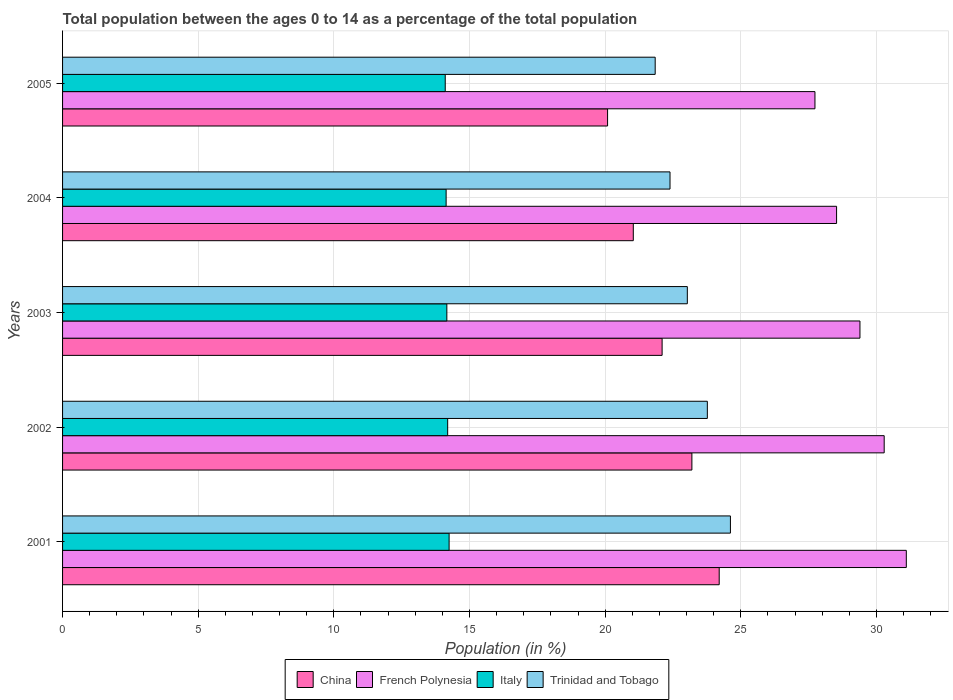How many different coloured bars are there?
Offer a very short reply. 4. How many groups of bars are there?
Offer a very short reply. 5. Are the number of bars per tick equal to the number of legend labels?
Your answer should be very brief. Yes. How many bars are there on the 5th tick from the bottom?
Provide a succinct answer. 4. In how many cases, is the number of bars for a given year not equal to the number of legend labels?
Offer a very short reply. 0. What is the percentage of the population ages 0 to 14 in China in 2002?
Offer a terse response. 23.2. Across all years, what is the maximum percentage of the population ages 0 to 14 in Italy?
Keep it short and to the point. 14.25. Across all years, what is the minimum percentage of the population ages 0 to 14 in China?
Your answer should be very brief. 20.09. In which year was the percentage of the population ages 0 to 14 in French Polynesia maximum?
Your answer should be very brief. 2001. What is the total percentage of the population ages 0 to 14 in Trinidad and Tobago in the graph?
Keep it short and to the point. 115.65. What is the difference between the percentage of the population ages 0 to 14 in Italy in 2001 and that in 2005?
Make the answer very short. 0.14. What is the difference between the percentage of the population ages 0 to 14 in French Polynesia in 2004 and the percentage of the population ages 0 to 14 in China in 2005?
Keep it short and to the point. 8.44. What is the average percentage of the population ages 0 to 14 in Italy per year?
Your response must be concise. 14.17. In the year 2005, what is the difference between the percentage of the population ages 0 to 14 in Trinidad and Tobago and percentage of the population ages 0 to 14 in Italy?
Provide a short and direct response. 7.74. In how many years, is the percentage of the population ages 0 to 14 in Italy greater than 1 ?
Keep it short and to the point. 5. What is the ratio of the percentage of the population ages 0 to 14 in Italy in 2001 to that in 2002?
Offer a terse response. 1. What is the difference between the highest and the second highest percentage of the population ages 0 to 14 in China?
Offer a very short reply. 1.01. What is the difference between the highest and the lowest percentage of the population ages 0 to 14 in China?
Your answer should be very brief. 4.11. In how many years, is the percentage of the population ages 0 to 14 in Italy greater than the average percentage of the population ages 0 to 14 in Italy taken over all years?
Give a very brief answer. 2. How many bars are there?
Your answer should be compact. 20. What is the difference between two consecutive major ticks on the X-axis?
Provide a short and direct response. 5. Are the values on the major ticks of X-axis written in scientific E-notation?
Give a very brief answer. No. Does the graph contain any zero values?
Your answer should be compact. No. Where does the legend appear in the graph?
Offer a terse response. Bottom center. How many legend labels are there?
Offer a very short reply. 4. What is the title of the graph?
Give a very brief answer. Total population between the ages 0 to 14 as a percentage of the total population. Does "Vanuatu" appear as one of the legend labels in the graph?
Provide a succinct answer. No. What is the label or title of the X-axis?
Offer a very short reply. Population (in %). What is the label or title of the Y-axis?
Keep it short and to the point. Years. What is the Population (in %) in China in 2001?
Make the answer very short. 24.2. What is the Population (in %) of French Polynesia in 2001?
Make the answer very short. 31.1. What is the Population (in %) in Italy in 2001?
Provide a short and direct response. 14.25. What is the Population (in %) in Trinidad and Tobago in 2001?
Provide a short and direct response. 24.62. What is the Population (in %) of China in 2002?
Offer a terse response. 23.2. What is the Population (in %) in French Polynesia in 2002?
Your response must be concise. 30.29. What is the Population (in %) of Italy in 2002?
Provide a succinct answer. 14.2. What is the Population (in %) of Trinidad and Tobago in 2002?
Your answer should be compact. 23.77. What is the Population (in %) in China in 2003?
Ensure brevity in your answer.  22.1. What is the Population (in %) in French Polynesia in 2003?
Give a very brief answer. 29.39. What is the Population (in %) in Italy in 2003?
Provide a succinct answer. 14.16. What is the Population (in %) of Trinidad and Tobago in 2003?
Your answer should be compact. 23.03. What is the Population (in %) of China in 2004?
Give a very brief answer. 21.04. What is the Population (in %) of French Polynesia in 2004?
Ensure brevity in your answer.  28.53. What is the Population (in %) in Italy in 2004?
Give a very brief answer. 14.14. What is the Population (in %) in Trinidad and Tobago in 2004?
Your answer should be compact. 22.39. What is the Population (in %) in China in 2005?
Offer a terse response. 20.09. What is the Population (in %) in French Polynesia in 2005?
Provide a succinct answer. 27.73. What is the Population (in %) in Italy in 2005?
Give a very brief answer. 14.11. What is the Population (in %) of Trinidad and Tobago in 2005?
Your answer should be compact. 21.84. Across all years, what is the maximum Population (in %) in China?
Keep it short and to the point. 24.2. Across all years, what is the maximum Population (in %) of French Polynesia?
Give a very brief answer. 31.1. Across all years, what is the maximum Population (in %) in Italy?
Your answer should be very brief. 14.25. Across all years, what is the maximum Population (in %) in Trinidad and Tobago?
Offer a very short reply. 24.62. Across all years, what is the minimum Population (in %) in China?
Your response must be concise. 20.09. Across all years, what is the minimum Population (in %) of French Polynesia?
Ensure brevity in your answer.  27.73. Across all years, what is the minimum Population (in %) of Italy?
Give a very brief answer. 14.11. Across all years, what is the minimum Population (in %) of Trinidad and Tobago?
Provide a short and direct response. 21.84. What is the total Population (in %) in China in the graph?
Provide a succinct answer. 110.63. What is the total Population (in %) in French Polynesia in the graph?
Your response must be concise. 147.04. What is the total Population (in %) of Italy in the graph?
Make the answer very short. 70.85. What is the total Population (in %) of Trinidad and Tobago in the graph?
Your answer should be compact. 115.65. What is the difference between the Population (in %) in China in 2001 and that in 2002?
Your answer should be compact. 1.01. What is the difference between the Population (in %) in French Polynesia in 2001 and that in 2002?
Your response must be concise. 0.82. What is the difference between the Population (in %) of Italy in 2001 and that in 2002?
Provide a succinct answer. 0.05. What is the difference between the Population (in %) in Trinidad and Tobago in 2001 and that in 2002?
Your answer should be compact. 0.85. What is the difference between the Population (in %) in China in 2001 and that in 2003?
Keep it short and to the point. 2.1. What is the difference between the Population (in %) in French Polynesia in 2001 and that in 2003?
Provide a succinct answer. 1.71. What is the difference between the Population (in %) of Italy in 2001 and that in 2003?
Make the answer very short. 0.08. What is the difference between the Population (in %) in Trinidad and Tobago in 2001 and that in 2003?
Provide a short and direct response. 1.59. What is the difference between the Population (in %) in China in 2001 and that in 2004?
Offer a very short reply. 3.17. What is the difference between the Population (in %) in French Polynesia in 2001 and that in 2004?
Provide a short and direct response. 2.57. What is the difference between the Population (in %) of Italy in 2001 and that in 2004?
Ensure brevity in your answer.  0.11. What is the difference between the Population (in %) in Trinidad and Tobago in 2001 and that in 2004?
Offer a terse response. 2.23. What is the difference between the Population (in %) in China in 2001 and that in 2005?
Make the answer very short. 4.11. What is the difference between the Population (in %) of French Polynesia in 2001 and that in 2005?
Ensure brevity in your answer.  3.37. What is the difference between the Population (in %) of Italy in 2001 and that in 2005?
Provide a short and direct response. 0.14. What is the difference between the Population (in %) of Trinidad and Tobago in 2001 and that in 2005?
Your answer should be compact. 2.77. What is the difference between the Population (in %) in China in 2002 and that in 2003?
Ensure brevity in your answer.  1.1. What is the difference between the Population (in %) in French Polynesia in 2002 and that in 2003?
Give a very brief answer. 0.89. What is the difference between the Population (in %) in Italy in 2002 and that in 2003?
Offer a terse response. 0.03. What is the difference between the Population (in %) in Trinidad and Tobago in 2002 and that in 2003?
Provide a short and direct response. 0.74. What is the difference between the Population (in %) in China in 2002 and that in 2004?
Ensure brevity in your answer.  2.16. What is the difference between the Population (in %) in French Polynesia in 2002 and that in 2004?
Provide a short and direct response. 1.75. What is the difference between the Population (in %) in Italy in 2002 and that in 2004?
Offer a terse response. 0.06. What is the difference between the Population (in %) in Trinidad and Tobago in 2002 and that in 2004?
Provide a short and direct response. 1.38. What is the difference between the Population (in %) of China in 2002 and that in 2005?
Offer a terse response. 3.11. What is the difference between the Population (in %) of French Polynesia in 2002 and that in 2005?
Give a very brief answer. 2.55. What is the difference between the Population (in %) of Italy in 2002 and that in 2005?
Your answer should be very brief. 0.09. What is the difference between the Population (in %) in Trinidad and Tobago in 2002 and that in 2005?
Your answer should be compact. 1.92. What is the difference between the Population (in %) in China in 2003 and that in 2004?
Ensure brevity in your answer.  1.06. What is the difference between the Population (in %) in French Polynesia in 2003 and that in 2004?
Your answer should be very brief. 0.86. What is the difference between the Population (in %) of Italy in 2003 and that in 2004?
Make the answer very short. 0.03. What is the difference between the Population (in %) in Trinidad and Tobago in 2003 and that in 2004?
Your response must be concise. 0.64. What is the difference between the Population (in %) in China in 2003 and that in 2005?
Your answer should be compact. 2.01. What is the difference between the Population (in %) of French Polynesia in 2003 and that in 2005?
Offer a terse response. 1.66. What is the difference between the Population (in %) of Italy in 2003 and that in 2005?
Your answer should be compact. 0.06. What is the difference between the Population (in %) of Trinidad and Tobago in 2003 and that in 2005?
Provide a short and direct response. 1.18. What is the difference between the Population (in %) in China in 2004 and that in 2005?
Provide a succinct answer. 0.95. What is the difference between the Population (in %) in French Polynesia in 2004 and that in 2005?
Give a very brief answer. 0.8. What is the difference between the Population (in %) of Italy in 2004 and that in 2005?
Ensure brevity in your answer.  0.03. What is the difference between the Population (in %) of Trinidad and Tobago in 2004 and that in 2005?
Your response must be concise. 0.55. What is the difference between the Population (in %) in China in 2001 and the Population (in %) in French Polynesia in 2002?
Make the answer very short. -6.08. What is the difference between the Population (in %) of China in 2001 and the Population (in %) of Italy in 2002?
Provide a short and direct response. 10.01. What is the difference between the Population (in %) in China in 2001 and the Population (in %) in Trinidad and Tobago in 2002?
Ensure brevity in your answer.  0.44. What is the difference between the Population (in %) of French Polynesia in 2001 and the Population (in %) of Italy in 2002?
Ensure brevity in your answer.  16.91. What is the difference between the Population (in %) in French Polynesia in 2001 and the Population (in %) in Trinidad and Tobago in 2002?
Offer a terse response. 7.33. What is the difference between the Population (in %) in Italy in 2001 and the Population (in %) in Trinidad and Tobago in 2002?
Provide a succinct answer. -9.52. What is the difference between the Population (in %) in China in 2001 and the Population (in %) in French Polynesia in 2003?
Offer a terse response. -5.19. What is the difference between the Population (in %) of China in 2001 and the Population (in %) of Italy in 2003?
Ensure brevity in your answer.  10.04. What is the difference between the Population (in %) of China in 2001 and the Population (in %) of Trinidad and Tobago in 2003?
Your answer should be compact. 1.17. What is the difference between the Population (in %) in French Polynesia in 2001 and the Population (in %) in Italy in 2003?
Ensure brevity in your answer.  16.94. What is the difference between the Population (in %) of French Polynesia in 2001 and the Population (in %) of Trinidad and Tobago in 2003?
Provide a succinct answer. 8.07. What is the difference between the Population (in %) in Italy in 2001 and the Population (in %) in Trinidad and Tobago in 2003?
Make the answer very short. -8.78. What is the difference between the Population (in %) of China in 2001 and the Population (in %) of French Polynesia in 2004?
Offer a terse response. -4.33. What is the difference between the Population (in %) in China in 2001 and the Population (in %) in Italy in 2004?
Offer a terse response. 10.07. What is the difference between the Population (in %) in China in 2001 and the Population (in %) in Trinidad and Tobago in 2004?
Provide a succinct answer. 1.81. What is the difference between the Population (in %) of French Polynesia in 2001 and the Population (in %) of Italy in 2004?
Give a very brief answer. 16.96. What is the difference between the Population (in %) of French Polynesia in 2001 and the Population (in %) of Trinidad and Tobago in 2004?
Provide a succinct answer. 8.71. What is the difference between the Population (in %) of Italy in 2001 and the Population (in %) of Trinidad and Tobago in 2004?
Provide a short and direct response. -8.14. What is the difference between the Population (in %) of China in 2001 and the Population (in %) of French Polynesia in 2005?
Your response must be concise. -3.53. What is the difference between the Population (in %) of China in 2001 and the Population (in %) of Italy in 2005?
Offer a terse response. 10.1. What is the difference between the Population (in %) in China in 2001 and the Population (in %) in Trinidad and Tobago in 2005?
Provide a succinct answer. 2.36. What is the difference between the Population (in %) in French Polynesia in 2001 and the Population (in %) in Italy in 2005?
Provide a succinct answer. 17. What is the difference between the Population (in %) in French Polynesia in 2001 and the Population (in %) in Trinidad and Tobago in 2005?
Keep it short and to the point. 9.26. What is the difference between the Population (in %) in Italy in 2001 and the Population (in %) in Trinidad and Tobago in 2005?
Provide a short and direct response. -7.6. What is the difference between the Population (in %) in China in 2002 and the Population (in %) in French Polynesia in 2003?
Your response must be concise. -6.2. What is the difference between the Population (in %) of China in 2002 and the Population (in %) of Italy in 2003?
Offer a terse response. 9.03. What is the difference between the Population (in %) in China in 2002 and the Population (in %) in Trinidad and Tobago in 2003?
Offer a very short reply. 0.17. What is the difference between the Population (in %) in French Polynesia in 2002 and the Population (in %) in Italy in 2003?
Your answer should be very brief. 16.12. What is the difference between the Population (in %) of French Polynesia in 2002 and the Population (in %) of Trinidad and Tobago in 2003?
Make the answer very short. 7.26. What is the difference between the Population (in %) of Italy in 2002 and the Population (in %) of Trinidad and Tobago in 2003?
Give a very brief answer. -8.83. What is the difference between the Population (in %) of China in 2002 and the Population (in %) of French Polynesia in 2004?
Your answer should be very brief. -5.33. What is the difference between the Population (in %) of China in 2002 and the Population (in %) of Italy in 2004?
Your response must be concise. 9.06. What is the difference between the Population (in %) in China in 2002 and the Population (in %) in Trinidad and Tobago in 2004?
Your response must be concise. 0.81. What is the difference between the Population (in %) of French Polynesia in 2002 and the Population (in %) of Italy in 2004?
Your answer should be very brief. 16.15. What is the difference between the Population (in %) in French Polynesia in 2002 and the Population (in %) in Trinidad and Tobago in 2004?
Provide a short and direct response. 7.89. What is the difference between the Population (in %) in Italy in 2002 and the Population (in %) in Trinidad and Tobago in 2004?
Keep it short and to the point. -8.2. What is the difference between the Population (in %) of China in 2002 and the Population (in %) of French Polynesia in 2005?
Ensure brevity in your answer.  -4.54. What is the difference between the Population (in %) of China in 2002 and the Population (in %) of Italy in 2005?
Provide a succinct answer. 9.09. What is the difference between the Population (in %) in China in 2002 and the Population (in %) in Trinidad and Tobago in 2005?
Your answer should be compact. 1.35. What is the difference between the Population (in %) in French Polynesia in 2002 and the Population (in %) in Italy in 2005?
Your answer should be compact. 16.18. What is the difference between the Population (in %) in French Polynesia in 2002 and the Population (in %) in Trinidad and Tobago in 2005?
Ensure brevity in your answer.  8.44. What is the difference between the Population (in %) of Italy in 2002 and the Population (in %) of Trinidad and Tobago in 2005?
Offer a very short reply. -7.65. What is the difference between the Population (in %) of China in 2003 and the Population (in %) of French Polynesia in 2004?
Your answer should be very brief. -6.43. What is the difference between the Population (in %) of China in 2003 and the Population (in %) of Italy in 2004?
Offer a terse response. 7.96. What is the difference between the Population (in %) of China in 2003 and the Population (in %) of Trinidad and Tobago in 2004?
Make the answer very short. -0.29. What is the difference between the Population (in %) in French Polynesia in 2003 and the Population (in %) in Italy in 2004?
Your answer should be compact. 15.25. What is the difference between the Population (in %) of French Polynesia in 2003 and the Population (in %) of Trinidad and Tobago in 2004?
Give a very brief answer. 7. What is the difference between the Population (in %) in Italy in 2003 and the Population (in %) in Trinidad and Tobago in 2004?
Keep it short and to the point. -8.23. What is the difference between the Population (in %) in China in 2003 and the Population (in %) in French Polynesia in 2005?
Provide a succinct answer. -5.63. What is the difference between the Population (in %) of China in 2003 and the Population (in %) of Italy in 2005?
Give a very brief answer. 7.99. What is the difference between the Population (in %) in China in 2003 and the Population (in %) in Trinidad and Tobago in 2005?
Provide a short and direct response. 0.26. What is the difference between the Population (in %) in French Polynesia in 2003 and the Population (in %) in Italy in 2005?
Ensure brevity in your answer.  15.29. What is the difference between the Population (in %) of French Polynesia in 2003 and the Population (in %) of Trinidad and Tobago in 2005?
Your response must be concise. 7.55. What is the difference between the Population (in %) of Italy in 2003 and the Population (in %) of Trinidad and Tobago in 2005?
Provide a short and direct response. -7.68. What is the difference between the Population (in %) in China in 2004 and the Population (in %) in French Polynesia in 2005?
Make the answer very short. -6.7. What is the difference between the Population (in %) of China in 2004 and the Population (in %) of Italy in 2005?
Give a very brief answer. 6.93. What is the difference between the Population (in %) in China in 2004 and the Population (in %) in Trinidad and Tobago in 2005?
Ensure brevity in your answer.  -0.81. What is the difference between the Population (in %) in French Polynesia in 2004 and the Population (in %) in Italy in 2005?
Offer a very short reply. 14.43. What is the difference between the Population (in %) in French Polynesia in 2004 and the Population (in %) in Trinidad and Tobago in 2005?
Offer a terse response. 6.69. What is the difference between the Population (in %) in Italy in 2004 and the Population (in %) in Trinidad and Tobago in 2005?
Your answer should be compact. -7.71. What is the average Population (in %) in China per year?
Keep it short and to the point. 22.13. What is the average Population (in %) in French Polynesia per year?
Provide a short and direct response. 29.41. What is the average Population (in %) of Italy per year?
Ensure brevity in your answer.  14.17. What is the average Population (in %) in Trinidad and Tobago per year?
Keep it short and to the point. 23.13. In the year 2001, what is the difference between the Population (in %) of China and Population (in %) of French Polynesia?
Provide a succinct answer. -6.9. In the year 2001, what is the difference between the Population (in %) of China and Population (in %) of Italy?
Offer a terse response. 9.96. In the year 2001, what is the difference between the Population (in %) in China and Population (in %) in Trinidad and Tobago?
Give a very brief answer. -0.41. In the year 2001, what is the difference between the Population (in %) in French Polynesia and Population (in %) in Italy?
Keep it short and to the point. 16.85. In the year 2001, what is the difference between the Population (in %) in French Polynesia and Population (in %) in Trinidad and Tobago?
Keep it short and to the point. 6.48. In the year 2001, what is the difference between the Population (in %) in Italy and Population (in %) in Trinidad and Tobago?
Your answer should be compact. -10.37. In the year 2002, what is the difference between the Population (in %) in China and Population (in %) in French Polynesia?
Your answer should be very brief. -7.09. In the year 2002, what is the difference between the Population (in %) in China and Population (in %) in Italy?
Keep it short and to the point. 9. In the year 2002, what is the difference between the Population (in %) in China and Population (in %) in Trinidad and Tobago?
Ensure brevity in your answer.  -0.57. In the year 2002, what is the difference between the Population (in %) in French Polynesia and Population (in %) in Italy?
Offer a very short reply. 16.09. In the year 2002, what is the difference between the Population (in %) of French Polynesia and Population (in %) of Trinidad and Tobago?
Keep it short and to the point. 6.52. In the year 2002, what is the difference between the Population (in %) of Italy and Population (in %) of Trinidad and Tobago?
Provide a short and direct response. -9.57. In the year 2003, what is the difference between the Population (in %) in China and Population (in %) in French Polynesia?
Ensure brevity in your answer.  -7.29. In the year 2003, what is the difference between the Population (in %) of China and Population (in %) of Italy?
Make the answer very short. 7.94. In the year 2003, what is the difference between the Population (in %) in China and Population (in %) in Trinidad and Tobago?
Your response must be concise. -0.93. In the year 2003, what is the difference between the Population (in %) in French Polynesia and Population (in %) in Italy?
Offer a terse response. 15.23. In the year 2003, what is the difference between the Population (in %) in French Polynesia and Population (in %) in Trinidad and Tobago?
Your response must be concise. 6.36. In the year 2003, what is the difference between the Population (in %) in Italy and Population (in %) in Trinidad and Tobago?
Offer a very short reply. -8.86. In the year 2004, what is the difference between the Population (in %) of China and Population (in %) of French Polynesia?
Your answer should be compact. -7.49. In the year 2004, what is the difference between the Population (in %) in China and Population (in %) in Italy?
Provide a succinct answer. 6.9. In the year 2004, what is the difference between the Population (in %) of China and Population (in %) of Trinidad and Tobago?
Ensure brevity in your answer.  -1.35. In the year 2004, what is the difference between the Population (in %) in French Polynesia and Population (in %) in Italy?
Your response must be concise. 14.39. In the year 2004, what is the difference between the Population (in %) in French Polynesia and Population (in %) in Trinidad and Tobago?
Make the answer very short. 6.14. In the year 2004, what is the difference between the Population (in %) of Italy and Population (in %) of Trinidad and Tobago?
Offer a very short reply. -8.25. In the year 2005, what is the difference between the Population (in %) of China and Population (in %) of French Polynesia?
Keep it short and to the point. -7.64. In the year 2005, what is the difference between the Population (in %) in China and Population (in %) in Italy?
Provide a succinct answer. 5.98. In the year 2005, what is the difference between the Population (in %) in China and Population (in %) in Trinidad and Tobago?
Keep it short and to the point. -1.76. In the year 2005, what is the difference between the Population (in %) in French Polynesia and Population (in %) in Italy?
Make the answer very short. 13.63. In the year 2005, what is the difference between the Population (in %) in French Polynesia and Population (in %) in Trinidad and Tobago?
Your answer should be compact. 5.89. In the year 2005, what is the difference between the Population (in %) of Italy and Population (in %) of Trinidad and Tobago?
Offer a very short reply. -7.74. What is the ratio of the Population (in %) in China in 2001 to that in 2002?
Give a very brief answer. 1.04. What is the ratio of the Population (in %) of French Polynesia in 2001 to that in 2002?
Give a very brief answer. 1.03. What is the ratio of the Population (in %) of Italy in 2001 to that in 2002?
Provide a short and direct response. 1. What is the ratio of the Population (in %) in Trinidad and Tobago in 2001 to that in 2002?
Keep it short and to the point. 1.04. What is the ratio of the Population (in %) in China in 2001 to that in 2003?
Your answer should be compact. 1.1. What is the ratio of the Population (in %) of French Polynesia in 2001 to that in 2003?
Ensure brevity in your answer.  1.06. What is the ratio of the Population (in %) of Italy in 2001 to that in 2003?
Provide a succinct answer. 1.01. What is the ratio of the Population (in %) in Trinidad and Tobago in 2001 to that in 2003?
Your answer should be very brief. 1.07. What is the ratio of the Population (in %) in China in 2001 to that in 2004?
Your answer should be compact. 1.15. What is the ratio of the Population (in %) in French Polynesia in 2001 to that in 2004?
Provide a succinct answer. 1.09. What is the ratio of the Population (in %) of Italy in 2001 to that in 2004?
Give a very brief answer. 1.01. What is the ratio of the Population (in %) in Trinidad and Tobago in 2001 to that in 2004?
Keep it short and to the point. 1.1. What is the ratio of the Population (in %) in China in 2001 to that in 2005?
Your answer should be very brief. 1.2. What is the ratio of the Population (in %) in French Polynesia in 2001 to that in 2005?
Your answer should be very brief. 1.12. What is the ratio of the Population (in %) of Italy in 2001 to that in 2005?
Provide a succinct answer. 1.01. What is the ratio of the Population (in %) of Trinidad and Tobago in 2001 to that in 2005?
Make the answer very short. 1.13. What is the ratio of the Population (in %) in China in 2002 to that in 2003?
Keep it short and to the point. 1.05. What is the ratio of the Population (in %) in French Polynesia in 2002 to that in 2003?
Your response must be concise. 1.03. What is the ratio of the Population (in %) in Trinidad and Tobago in 2002 to that in 2003?
Your answer should be very brief. 1.03. What is the ratio of the Population (in %) in China in 2002 to that in 2004?
Provide a short and direct response. 1.1. What is the ratio of the Population (in %) of French Polynesia in 2002 to that in 2004?
Keep it short and to the point. 1.06. What is the ratio of the Population (in %) of Italy in 2002 to that in 2004?
Provide a succinct answer. 1. What is the ratio of the Population (in %) of Trinidad and Tobago in 2002 to that in 2004?
Your answer should be compact. 1.06. What is the ratio of the Population (in %) of China in 2002 to that in 2005?
Keep it short and to the point. 1.15. What is the ratio of the Population (in %) in French Polynesia in 2002 to that in 2005?
Provide a succinct answer. 1.09. What is the ratio of the Population (in %) of Italy in 2002 to that in 2005?
Make the answer very short. 1.01. What is the ratio of the Population (in %) in Trinidad and Tobago in 2002 to that in 2005?
Make the answer very short. 1.09. What is the ratio of the Population (in %) of China in 2003 to that in 2004?
Your response must be concise. 1.05. What is the ratio of the Population (in %) in French Polynesia in 2003 to that in 2004?
Your answer should be compact. 1.03. What is the ratio of the Population (in %) in Trinidad and Tobago in 2003 to that in 2004?
Give a very brief answer. 1.03. What is the ratio of the Population (in %) of China in 2003 to that in 2005?
Your answer should be compact. 1.1. What is the ratio of the Population (in %) of French Polynesia in 2003 to that in 2005?
Offer a terse response. 1.06. What is the ratio of the Population (in %) in Italy in 2003 to that in 2005?
Make the answer very short. 1. What is the ratio of the Population (in %) in Trinidad and Tobago in 2003 to that in 2005?
Your answer should be compact. 1.05. What is the ratio of the Population (in %) of China in 2004 to that in 2005?
Offer a terse response. 1.05. What is the ratio of the Population (in %) in French Polynesia in 2004 to that in 2005?
Keep it short and to the point. 1.03. What is the difference between the highest and the second highest Population (in %) in China?
Ensure brevity in your answer.  1.01. What is the difference between the highest and the second highest Population (in %) of French Polynesia?
Make the answer very short. 0.82. What is the difference between the highest and the second highest Population (in %) of Italy?
Make the answer very short. 0.05. What is the difference between the highest and the second highest Population (in %) in Trinidad and Tobago?
Offer a very short reply. 0.85. What is the difference between the highest and the lowest Population (in %) in China?
Provide a short and direct response. 4.11. What is the difference between the highest and the lowest Population (in %) in French Polynesia?
Ensure brevity in your answer.  3.37. What is the difference between the highest and the lowest Population (in %) of Italy?
Keep it short and to the point. 0.14. What is the difference between the highest and the lowest Population (in %) of Trinidad and Tobago?
Your answer should be very brief. 2.77. 